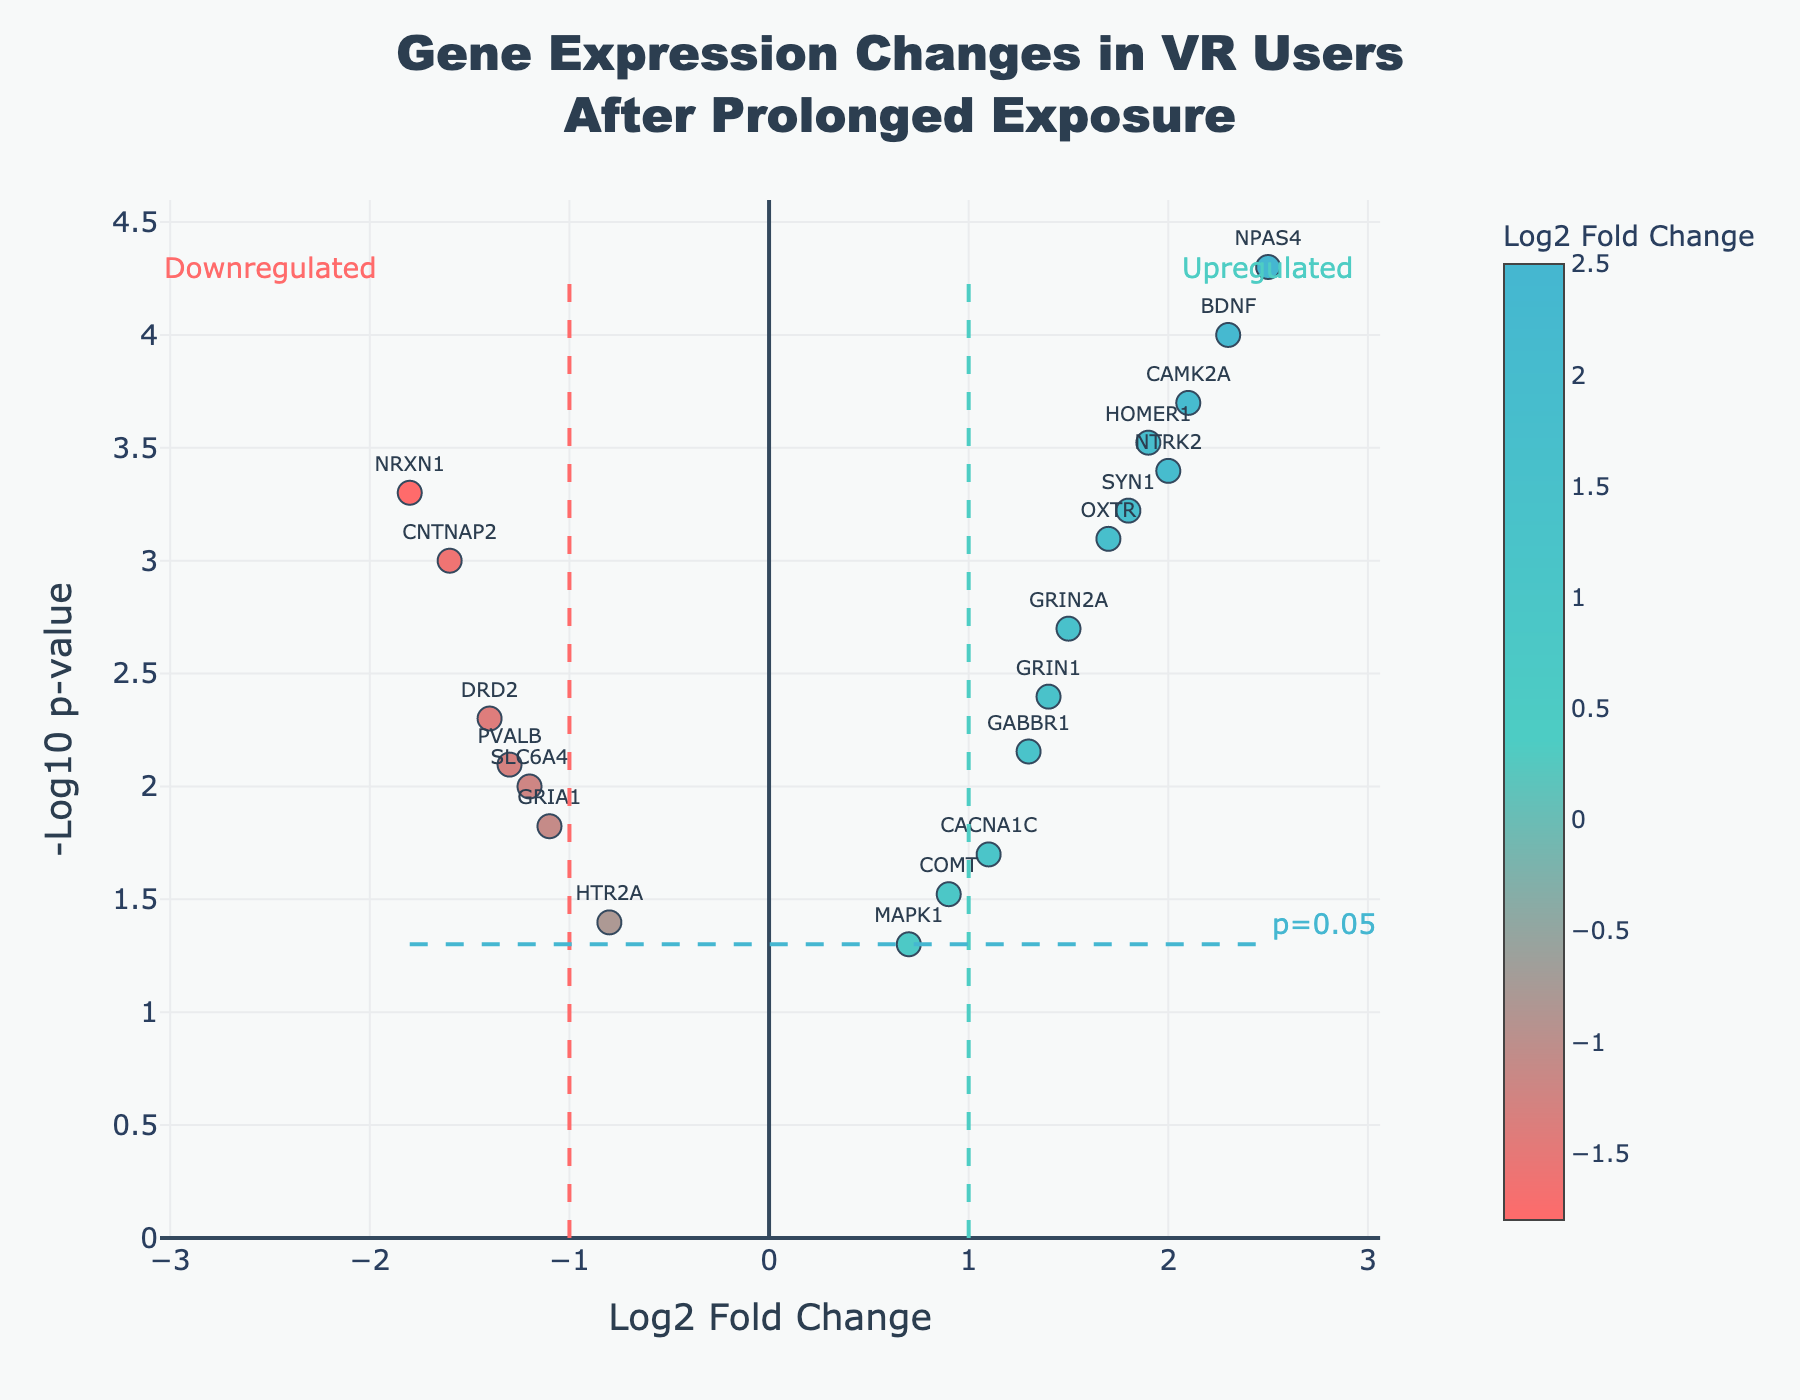How many genes are represented in the figure? Count the number of points on the plot, each representing a gene.
Answer: 19 What is the title of the volcano plot? The title is displayed at the top of the figure.
Answer: Gene Expression Changes in VR Users After Prolonged Exposure Which gene has the most significant p-value, and what is its corresponding log2 fold change? The most significant p-value corresponds to the point with the highest -log10(p-value) on the y-axis. Identify the gene label and its x-coordinate (log2 fold change). The highest point corresponds to NPAS4, with a log2 fold change of 2.5.
Answer: NPAS4, 2.5 What color represents the upregulated genes, and what is the fold change threshold for this category? Upregulated genes are typically indicated on the positive side of the x-axis (log2 fold change). The color and fold change threshold can be inferred from the color bar and vertical line annotations.
Answer: Green, threshold ≥ 1 How many genes have a log2 fold change greater than 1 and a p-value less than 0.05? Identify points in the figure that are to the right of the x=1 line and above the y=-log10(0.05) line. Count these points to get the answer. Nine genes are upregulated with these criteria (BDNF, GRIN2A, HOMER1, OXTR, CAMK2A, CACNA1C, GABBR1, SYN1, NTRK2, and NPAS4).
Answer: 10 Which downregulated gene (log2 fold change < -1) has the highest significance (lowest p-value)? Refer to the points on the left side (log2 fold change < -1) and identify the one with the highest -log10(p-value) on the y-axis. This point corresponds to NRXN1.
Answer: NRXN1 What are the log2 fold changes and p-values for the genes GRIN2A and DRD2? Locate these gene labels in the figure, and read their log2 fold changes from the x-axis and their p-values from the y-axis. GRIN2A has a log2 fold change of 1.5 and a p-value of 0.002 while DRD2 has a log2 fold change of -1.4 and a p-value of 0.005.
Answer: GRIN2A: 1.5, 0.002; DRD2: -1.4, 0.005 Are there more upregulated or downregulated genes with p-values less than 0.01? Count the number of points with p-values less than 0.01 (above -log10(0.01)) on each side of the x-axis. Compare these counts. There are 7 upregulated genes (BDNF, GRIN2A, HOMER1, OXTR, CAMK2A, SYN1, NPAS4) and 5 downregulated genes (NRXN1, SLC6A4, DRD2, CNTNAP2, PVALB).
Answer: Upregulated What threshold p-value is marked on the figure, and how is it visually indicated? The threshold p-value marked on the figure corresponds to 0.05. It is visually indicated by a horizontal dashed line labeled "p=0.05" on the y-axis.
Answer: 0.05, horizontal dashed line Which gene has a log2 fold change closest to zero, and is it upregulated or downregulated? Identify the point nearest to the center of the x-axis (log2 fold change = 0) and note its gene label and direction. MAPK1 is closest to zero with a log2 fold change of 0.7, and it's upregulated.
Answer: MAPK1, upregulated 